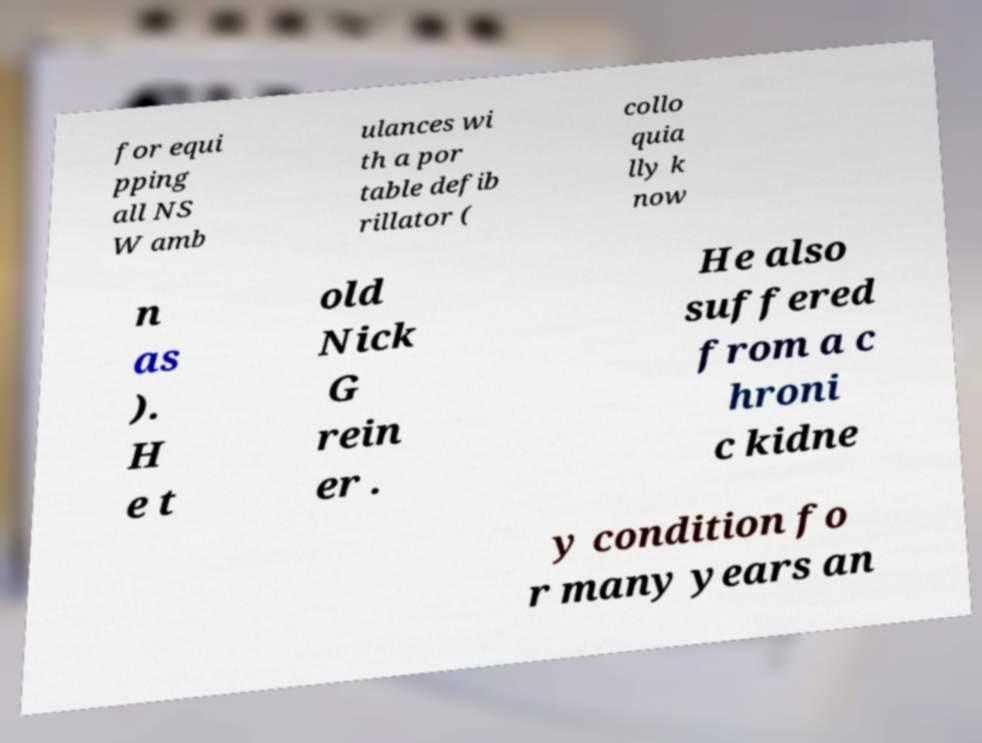Please read and relay the text visible in this image. What does it say? for equi pping all NS W amb ulances wi th a por table defib rillator ( collo quia lly k now n as ). H e t old Nick G rein er . He also suffered from a c hroni c kidne y condition fo r many years an 